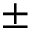<formula> <loc_0><loc_0><loc_500><loc_500>\pm</formula> 